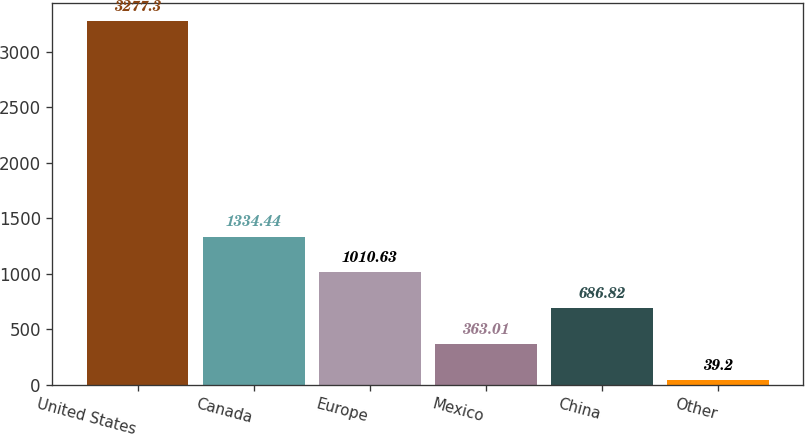Convert chart to OTSL. <chart><loc_0><loc_0><loc_500><loc_500><bar_chart><fcel>United States<fcel>Canada<fcel>Europe<fcel>Mexico<fcel>China<fcel>Other<nl><fcel>3277.3<fcel>1334.44<fcel>1010.63<fcel>363.01<fcel>686.82<fcel>39.2<nl></chart> 